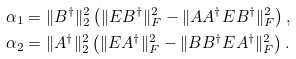Convert formula to latex. <formula><loc_0><loc_0><loc_500><loc_500>& \alpha _ { 1 } = \| B ^ { \dagger } \| _ { 2 } ^ { 2 } \left ( \| E B ^ { \dagger } \| _ { F } ^ { 2 } - \| A A ^ { \dagger } E B ^ { \dagger } \| _ { F } ^ { 2 } \right ) , \\ & \alpha _ { 2 } = \| A ^ { \dagger } \| _ { 2 } ^ { 2 } \left ( \| E A ^ { \dagger } \| _ { F } ^ { 2 } - \| B B ^ { \dagger } E A ^ { \dagger } \| _ { F } ^ { 2 } \right ) .</formula> 